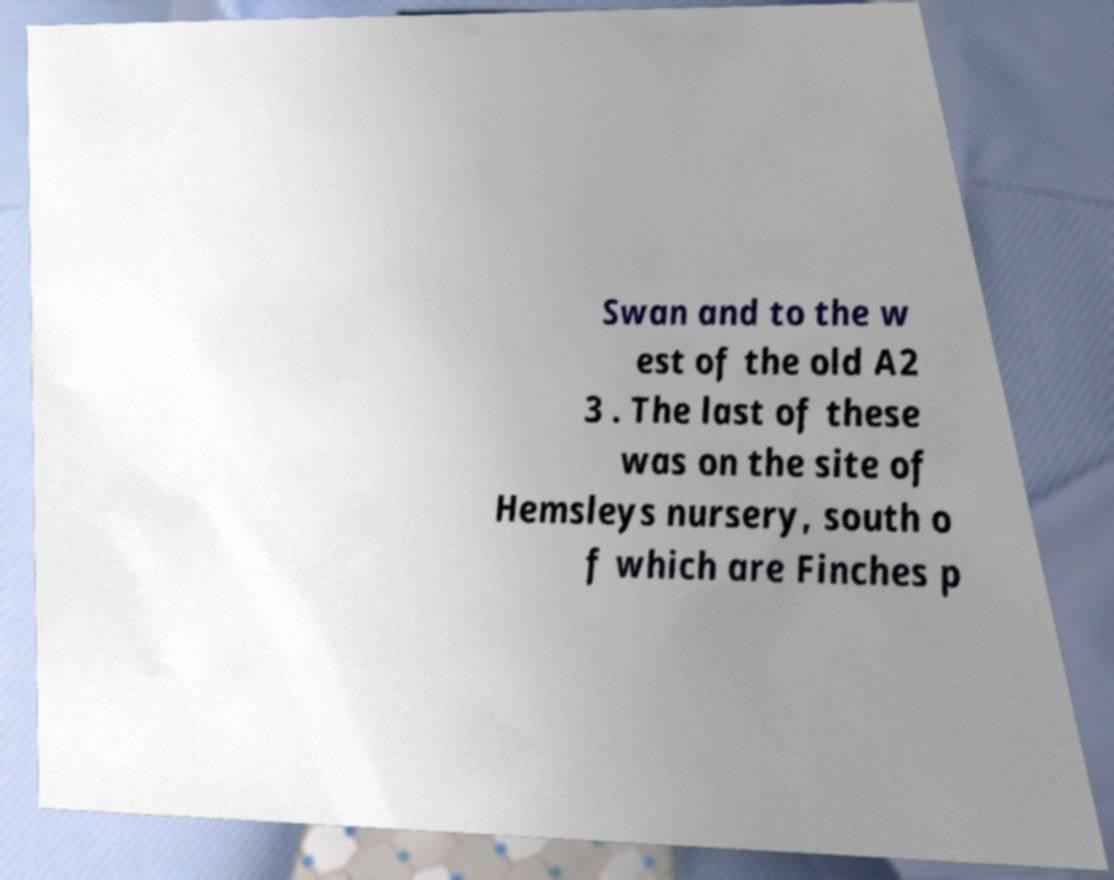There's text embedded in this image that I need extracted. Can you transcribe it verbatim? Swan and to the w est of the old A2 3 . The last of these was on the site of Hemsleys nursery, south o f which are Finches p 